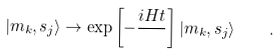Convert formula to latex. <formula><loc_0><loc_0><loc_500><loc_500>| m _ { k } , s _ { j } \rangle \rightarrow \exp \left [ - \frac { i H t } { } \right ] | m _ { k } , s _ { j } \rangle \quad .</formula> 